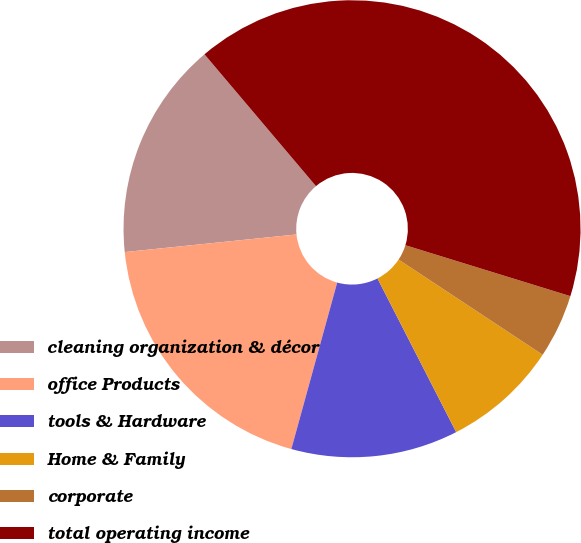<chart> <loc_0><loc_0><loc_500><loc_500><pie_chart><fcel>cleaning organization & décor<fcel>office Products<fcel>tools & Hardware<fcel>Home & Family<fcel>corporate<fcel>total operating income<nl><fcel>15.45%<fcel>19.09%<fcel>11.81%<fcel>8.17%<fcel>4.53%<fcel>40.93%<nl></chart> 